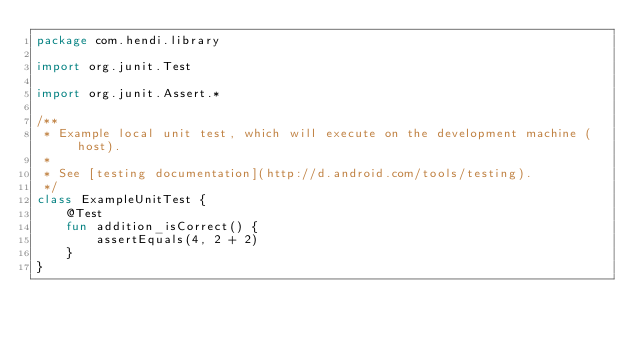Convert code to text. <code><loc_0><loc_0><loc_500><loc_500><_Kotlin_>package com.hendi.library

import org.junit.Test

import org.junit.Assert.*

/**
 * Example local unit test, which will execute on the development machine (host).
 *
 * See [testing documentation](http://d.android.com/tools/testing).
 */
class ExampleUnitTest {
    @Test
    fun addition_isCorrect() {
        assertEquals(4, 2 + 2)
    }
}</code> 